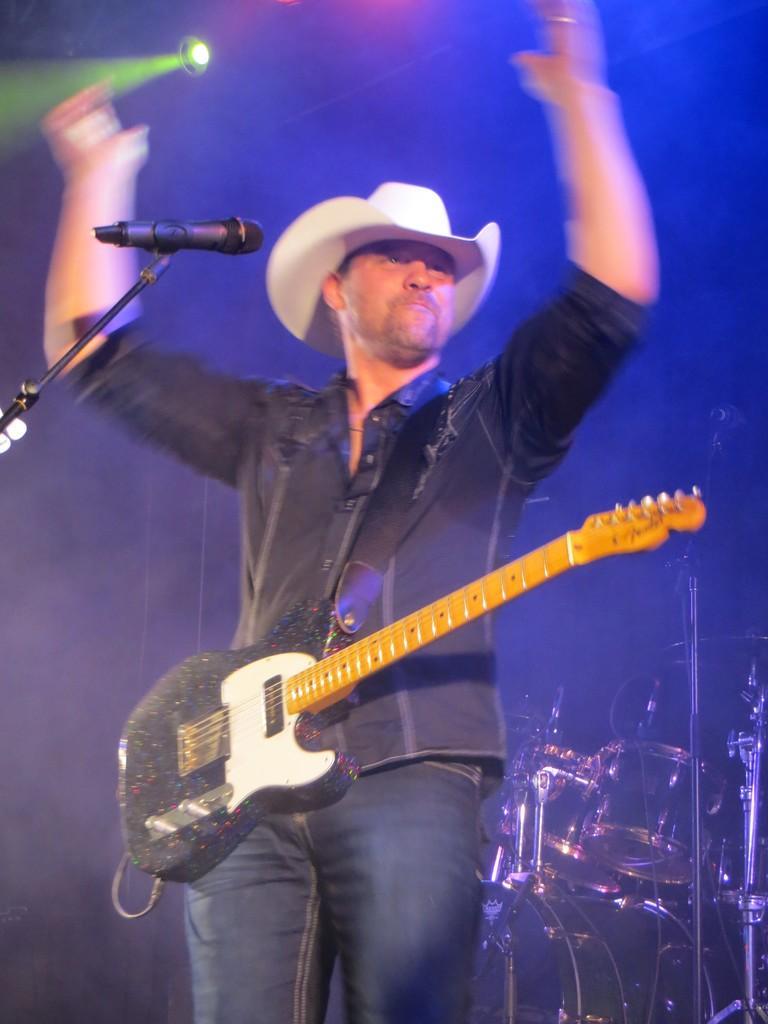What is the man in the image doing? The man is singing on a microphone and carrying a guitar. What instrument is the man holding in the image? The man is carrying a guitar. What can be seen in the background of the image? There are drums and lights in the background of the image. What type of lettuce is being used as a seat for the man in the image? There is no lettuce present in the image, and the man is not sitting on any seat. 